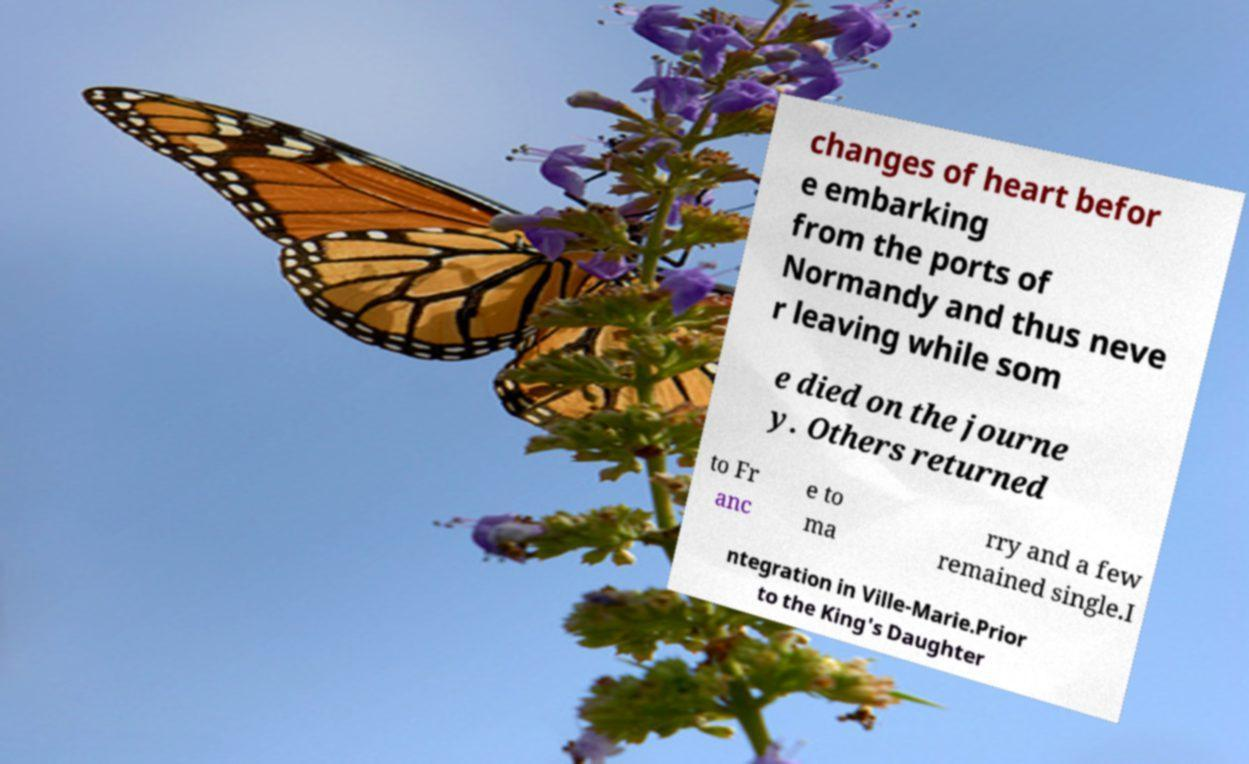Can you accurately transcribe the text from the provided image for me? changes of heart befor e embarking from the ports of Normandy and thus neve r leaving while som e died on the journe y. Others returned to Fr anc e to ma rry and a few remained single.I ntegration in Ville-Marie.Prior to the King's Daughter 